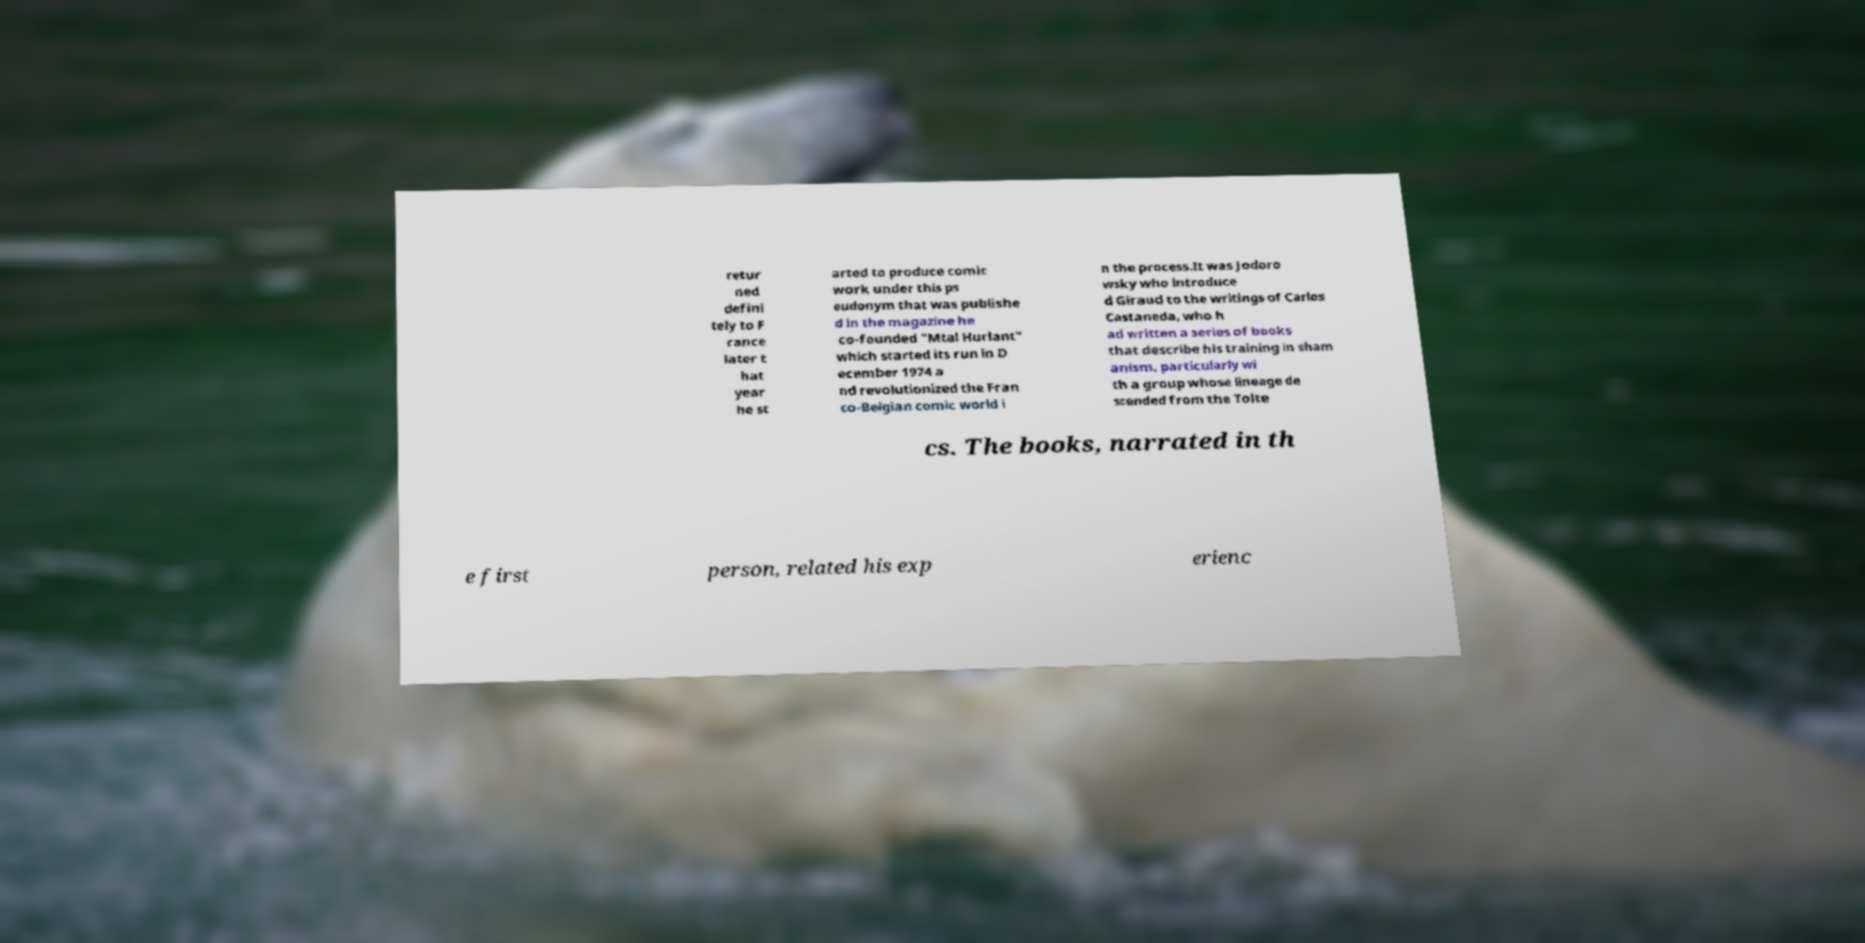Can you read and provide the text displayed in the image?This photo seems to have some interesting text. Can you extract and type it out for me? retur ned defini tely to F rance later t hat year he st arted to produce comic work under this ps eudonym that was publishe d in the magazine he co-founded "Mtal Hurlant" which started its run in D ecember 1974 a nd revolutionized the Fran co-Belgian comic world i n the process.It was Jodoro wsky who introduce d Giraud to the writings of Carlos Castaneda, who h ad written a series of books that describe his training in sham anism, particularly wi th a group whose lineage de scended from the Tolte cs. The books, narrated in th e first person, related his exp erienc 